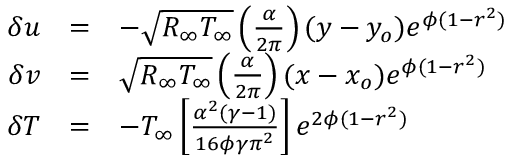<formula> <loc_0><loc_0><loc_500><loc_500>\begin{array} { r } { \begin{array} { r c l } { \delta u } & { = } & { - \sqrt { R _ { \infty } T _ { \infty } } \left ( \frac { \alpha } { 2 \pi } \right ) ( y - y _ { o } ) e ^ { \phi ( 1 - r ^ { 2 } ) } } \\ { \delta v } & { = } & { \sqrt { R _ { \infty } T _ { \infty } } \left ( \frac { \alpha } { 2 \pi } \right ) ( x - x _ { o } ) e ^ { \phi ( 1 - r ^ { 2 } ) } } \\ { \delta T } & { = } & { - T _ { \infty } \left [ \frac { \alpha ^ { 2 } ( \gamma - 1 ) } { 1 6 \phi \gamma \pi ^ { 2 } } \right ] e ^ { 2 \phi ( 1 - r ^ { 2 } ) } } \end{array} } \end{array}</formula> 